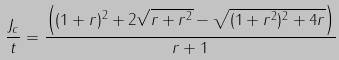Convert formula to latex. <formula><loc_0><loc_0><loc_500><loc_500>\frac { J _ { c } } { t } = \frac { \left ( ( 1 + r ) ^ { 2 } + 2 \sqrt { r + r ^ { 2 } } - \sqrt { ( 1 + r ^ { 2 } ) ^ { 2 } + 4 r } \right ) } { r + 1 }</formula> 